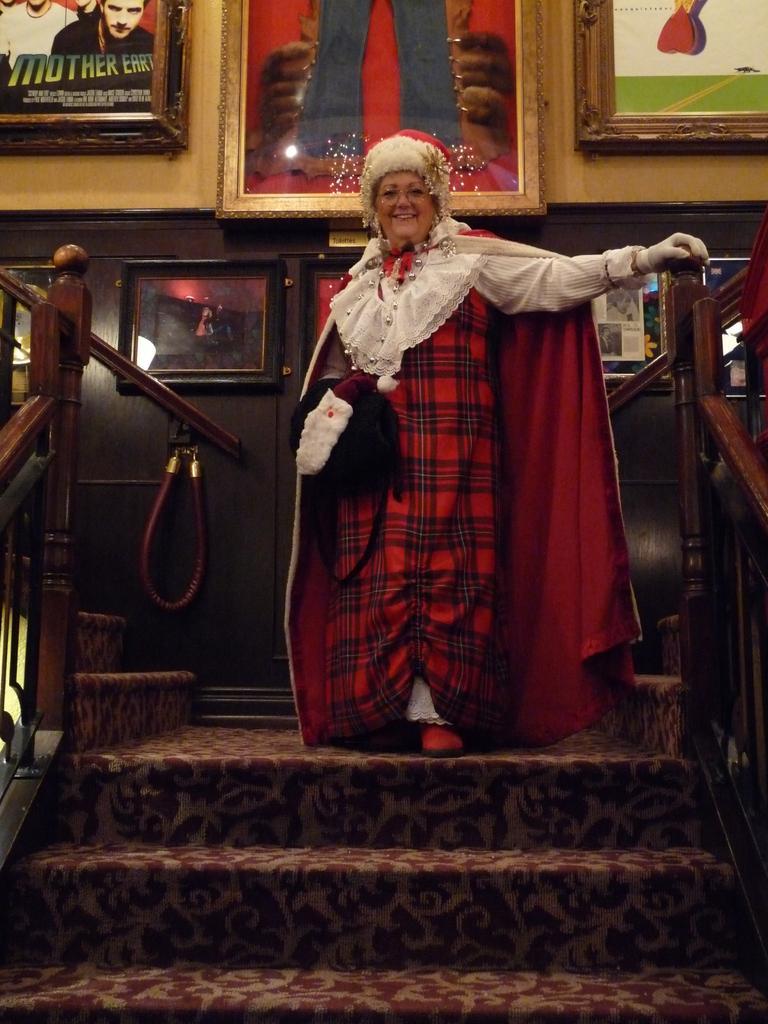Describe this image in one or two sentences. This image is taken indoors. In the background there is a wall with a few picture frames on it. At the bottom of the image there are a few stairs. On the left and right sides of the image there are two railings. In the middle of the image a woman is standing on the floor and she is with a smiling face. 